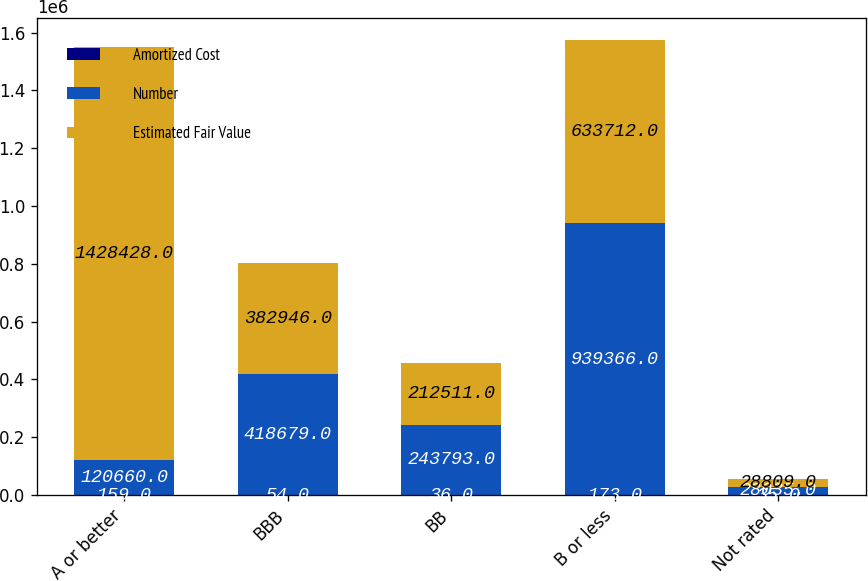Convert chart. <chart><loc_0><loc_0><loc_500><loc_500><stacked_bar_chart><ecel><fcel>A or better<fcel>BBB<fcel>BB<fcel>B or less<fcel>Not rated<nl><fcel>Amortized Cost<fcel>159<fcel>54<fcel>36<fcel>173<fcel>35<nl><fcel>Number<fcel>120660<fcel>418679<fcel>243793<fcel>939366<fcel>28035<nl><fcel>Estimated Fair Value<fcel>1.42843e+06<fcel>382946<fcel>212511<fcel>633712<fcel>28809<nl></chart> 